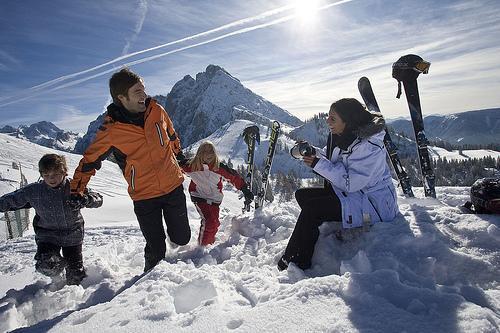How many children are shown?
Give a very brief answer. 2. How many people are pictured?
Give a very brief answer. 4. 